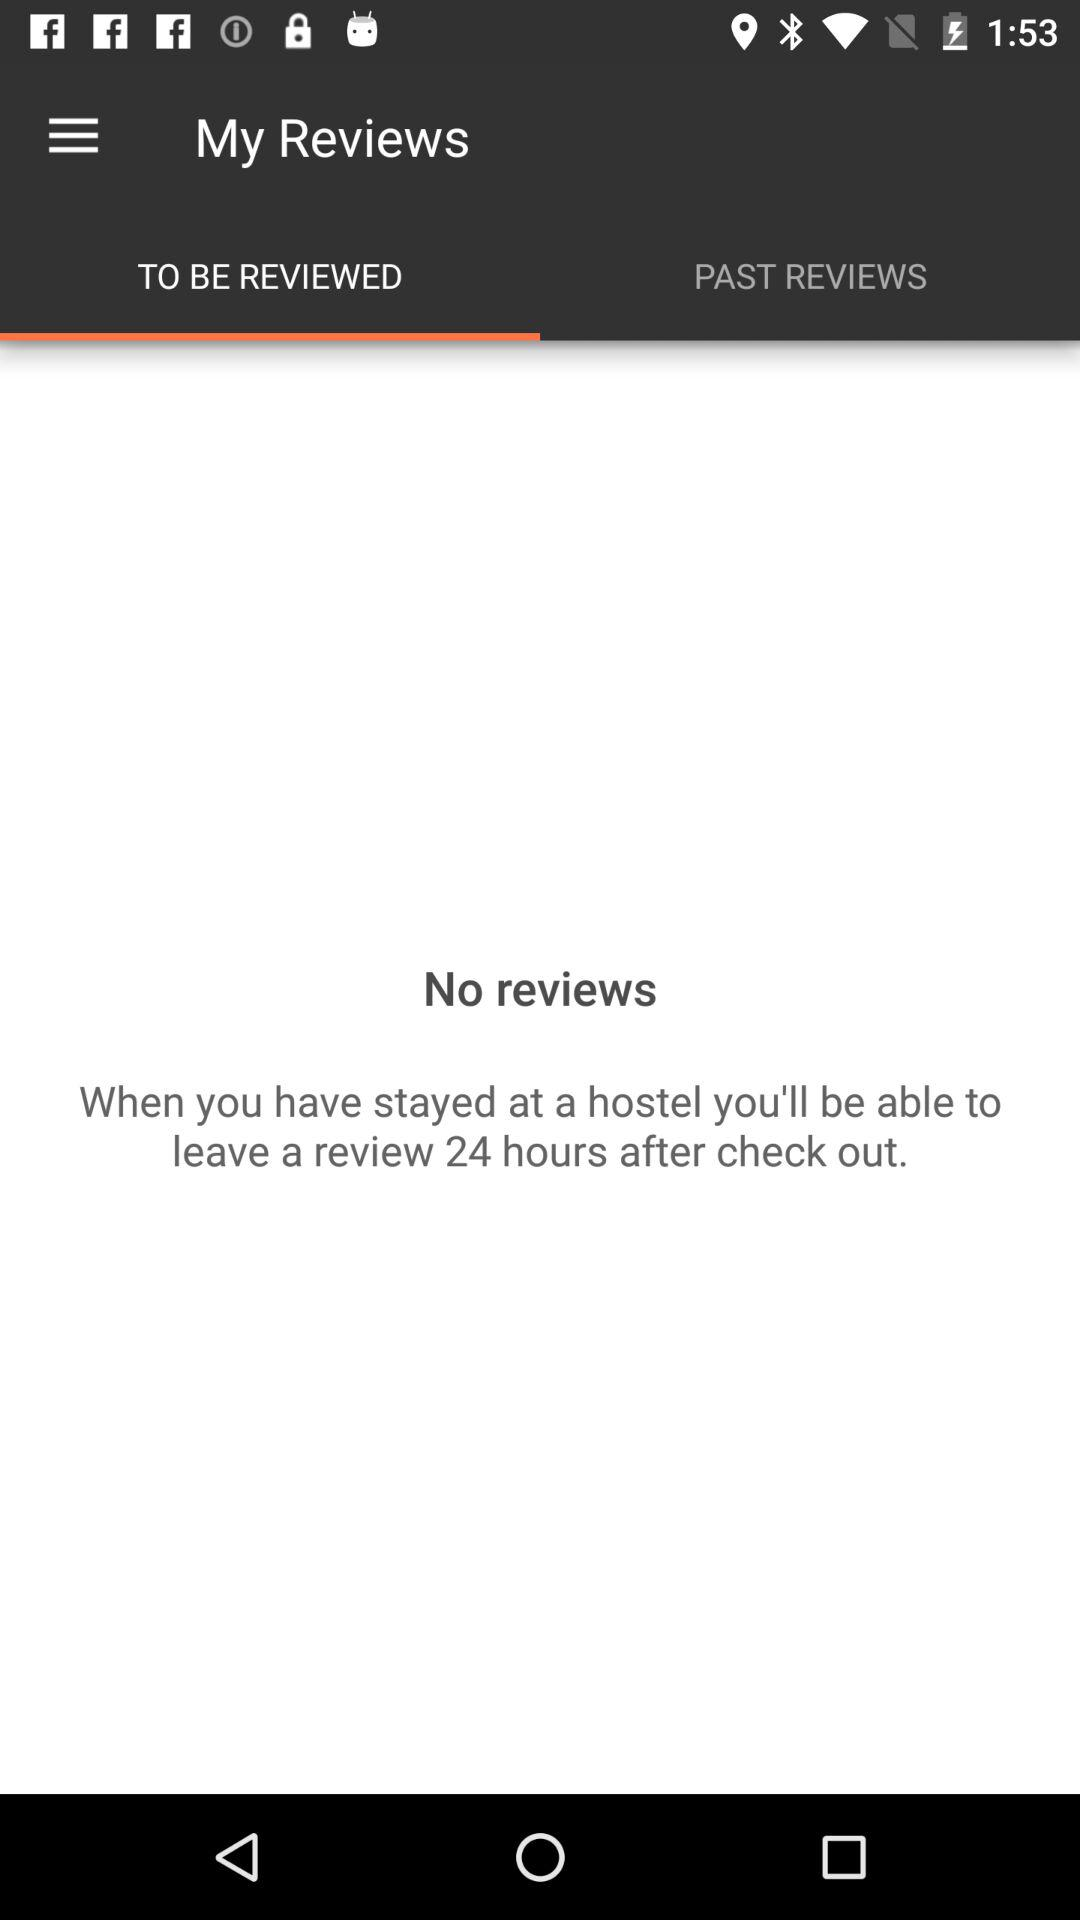After how many hours can I post a review? You can post a review 24 hours after check out. 